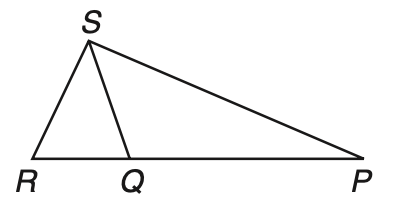Answer the mathemtical geometry problem and directly provide the correct option letter.
Question: If P Q \cong Q S, Q R \cong R S, and m \angle P R S = 72, what is the measure of \angle Q P S?
Choices: A: 27 B: 54 C: 63 D: 72 A 